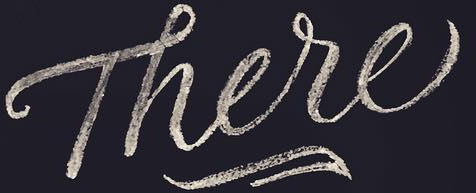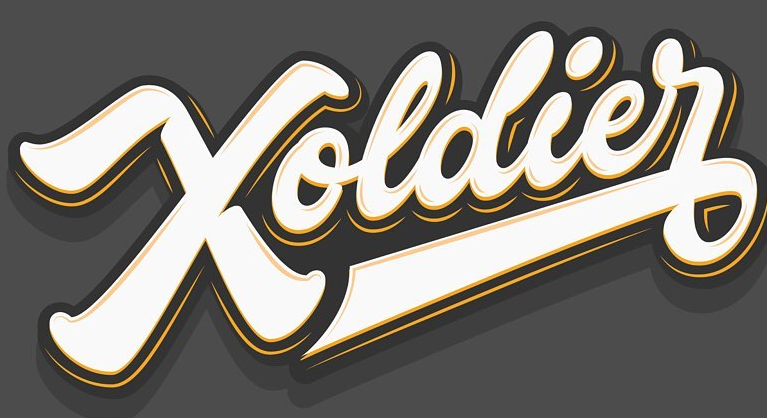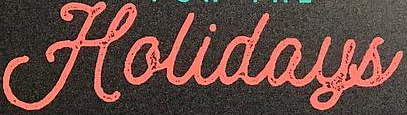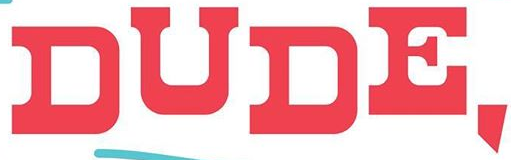What words can you see in these images in sequence, separated by a semicolon? There; Xoldier; Holidays; DUDE, 